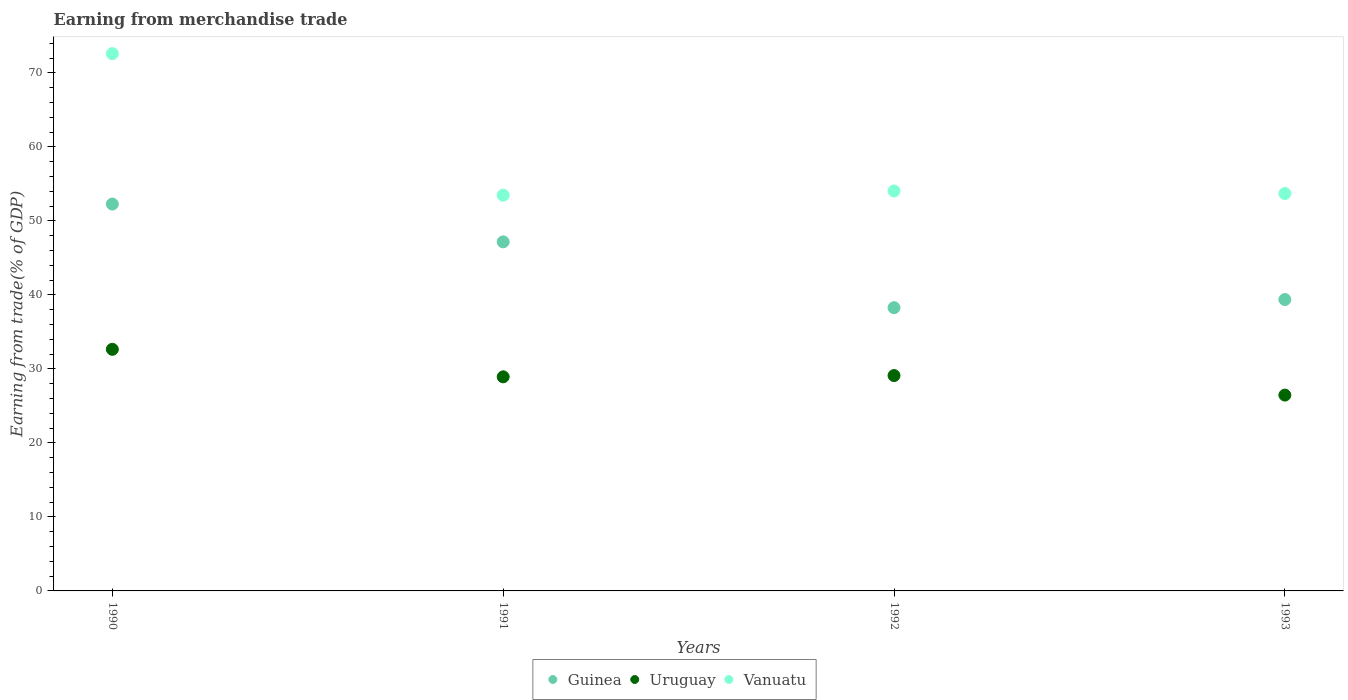What is the earnings from trade in Guinea in 1991?
Your response must be concise. 47.17. Across all years, what is the maximum earnings from trade in Guinea?
Your answer should be compact. 52.28. Across all years, what is the minimum earnings from trade in Uruguay?
Make the answer very short. 26.46. In which year was the earnings from trade in Vanuatu maximum?
Offer a very short reply. 1990. What is the total earnings from trade in Uruguay in the graph?
Offer a very short reply. 117.15. What is the difference between the earnings from trade in Vanuatu in 1990 and that in 1991?
Make the answer very short. 19.13. What is the difference between the earnings from trade in Guinea in 1991 and the earnings from trade in Vanuatu in 1990?
Provide a short and direct response. -25.43. What is the average earnings from trade in Uruguay per year?
Offer a terse response. 29.29. In the year 1993, what is the difference between the earnings from trade in Vanuatu and earnings from trade in Guinea?
Your answer should be compact. 14.33. In how many years, is the earnings from trade in Vanuatu greater than 66 %?
Offer a terse response. 1. What is the ratio of the earnings from trade in Vanuatu in 1990 to that in 1992?
Offer a very short reply. 1.34. Is the difference between the earnings from trade in Vanuatu in 1990 and 1991 greater than the difference between the earnings from trade in Guinea in 1990 and 1991?
Ensure brevity in your answer.  Yes. What is the difference between the highest and the second highest earnings from trade in Guinea?
Provide a short and direct response. 5.11. What is the difference between the highest and the lowest earnings from trade in Uruguay?
Offer a very short reply. 6.19. Is it the case that in every year, the sum of the earnings from trade in Uruguay and earnings from trade in Vanuatu  is greater than the earnings from trade in Guinea?
Your answer should be compact. Yes. Is the earnings from trade in Uruguay strictly greater than the earnings from trade in Vanuatu over the years?
Your answer should be compact. No. Is the earnings from trade in Uruguay strictly less than the earnings from trade in Guinea over the years?
Keep it short and to the point. Yes. How many dotlines are there?
Your answer should be compact. 3. How many years are there in the graph?
Keep it short and to the point. 4. What is the difference between two consecutive major ticks on the Y-axis?
Your response must be concise. 10. Does the graph contain any zero values?
Offer a terse response. No. How many legend labels are there?
Provide a short and direct response. 3. How are the legend labels stacked?
Your response must be concise. Horizontal. What is the title of the graph?
Make the answer very short. Earning from merchandise trade. Does "Nigeria" appear as one of the legend labels in the graph?
Ensure brevity in your answer.  No. What is the label or title of the Y-axis?
Your answer should be compact. Earning from trade(% of GDP). What is the Earning from trade(% of GDP) of Guinea in 1990?
Give a very brief answer. 52.28. What is the Earning from trade(% of GDP) in Uruguay in 1990?
Offer a very short reply. 32.65. What is the Earning from trade(% of GDP) of Vanuatu in 1990?
Your answer should be very brief. 72.6. What is the Earning from trade(% of GDP) of Guinea in 1991?
Your answer should be very brief. 47.17. What is the Earning from trade(% of GDP) in Uruguay in 1991?
Offer a very short reply. 28.93. What is the Earning from trade(% of GDP) in Vanuatu in 1991?
Provide a short and direct response. 53.48. What is the Earning from trade(% of GDP) in Guinea in 1992?
Your answer should be compact. 38.28. What is the Earning from trade(% of GDP) of Uruguay in 1992?
Give a very brief answer. 29.1. What is the Earning from trade(% of GDP) in Vanuatu in 1992?
Keep it short and to the point. 54.04. What is the Earning from trade(% of GDP) in Guinea in 1993?
Offer a terse response. 39.37. What is the Earning from trade(% of GDP) of Uruguay in 1993?
Offer a terse response. 26.46. What is the Earning from trade(% of GDP) in Vanuatu in 1993?
Give a very brief answer. 53.7. Across all years, what is the maximum Earning from trade(% of GDP) in Guinea?
Offer a terse response. 52.28. Across all years, what is the maximum Earning from trade(% of GDP) in Uruguay?
Make the answer very short. 32.65. Across all years, what is the maximum Earning from trade(% of GDP) in Vanuatu?
Give a very brief answer. 72.6. Across all years, what is the minimum Earning from trade(% of GDP) in Guinea?
Your answer should be compact. 38.28. Across all years, what is the minimum Earning from trade(% of GDP) in Uruguay?
Make the answer very short. 26.46. Across all years, what is the minimum Earning from trade(% of GDP) of Vanuatu?
Provide a succinct answer. 53.48. What is the total Earning from trade(% of GDP) in Guinea in the graph?
Provide a succinct answer. 177.09. What is the total Earning from trade(% of GDP) of Uruguay in the graph?
Keep it short and to the point. 117.15. What is the total Earning from trade(% of GDP) in Vanuatu in the graph?
Your answer should be compact. 233.82. What is the difference between the Earning from trade(% of GDP) of Guinea in 1990 and that in 1991?
Give a very brief answer. 5.11. What is the difference between the Earning from trade(% of GDP) in Uruguay in 1990 and that in 1991?
Make the answer very short. 3.72. What is the difference between the Earning from trade(% of GDP) in Vanuatu in 1990 and that in 1991?
Your response must be concise. 19.13. What is the difference between the Earning from trade(% of GDP) in Guinea in 1990 and that in 1992?
Ensure brevity in your answer.  14. What is the difference between the Earning from trade(% of GDP) of Uruguay in 1990 and that in 1992?
Your answer should be compact. 3.55. What is the difference between the Earning from trade(% of GDP) in Vanuatu in 1990 and that in 1992?
Your answer should be compact. 18.56. What is the difference between the Earning from trade(% of GDP) in Guinea in 1990 and that in 1993?
Ensure brevity in your answer.  12.9. What is the difference between the Earning from trade(% of GDP) of Uruguay in 1990 and that in 1993?
Provide a succinct answer. 6.19. What is the difference between the Earning from trade(% of GDP) of Vanuatu in 1990 and that in 1993?
Provide a succinct answer. 18.9. What is the difference between the Earning from trade(% of GDP) in Guinea in 1991 and that in 1992?
Give a very brief answer. 8.89. What is the difference between the Earning from trade(% of GDP) of Uruguay in 1991 and that in 1992?
Offer a terse response. -0.17. What is the difference between the Earning from trade(% of GDP) of Vanuatu in 1991 and that in 1992?
Give a very brief answer. -0.57. What is the difference between the Earning from trade(% of GDP) in Guinea in 1991 and that in 1993?
Your answer should be very brief. 7.8. What is the difference between the Earning from trade(% of GDP) in Uruguay in 1991 and that in 1993?
Provide a succinct answer. 2.47. What is the difference between the Earning from trade(% of GDP) of Vanuatu in 1991 and that in 1993?
Offer a terse response. -0.22. What is the difference between the Earning from trade(% of GDP) in Guinea in 1992 and that in 1993?
Keep it short and to the point. -1.1. What is the difference between the Earning from trade(% of GDP) of Uruguay in 1992 and that in 1993?
Your answer should be very brief. 2.64. What is the difference between the Earning from trade(% of GDP) of Vanuatu in 1992 and that in 1993?
Keep it short and to the point. 0.34. What is the difference between the Earning from trade(% of GDP) of Guinea in 1990 and the Earning from trade(% of GDP) of Uruguay in 1991?
Ensure brevity in your answer.  23.34. What is the difference between the Earning from trade(% of GDP) of Guinea in 1990 and the Earning from trade(% of GDP) of Vanuatu in 1991?
Your answer should be very brief. -1.2. What is the difference between the Earning from trade(% of GDP) of Uruguay in 1990 and the Earning from trade(% of GDP) of Vanuatu in 1991?
Offer a very short reply. -20.83. What is the difference between the Earning from trade(% of GDP) in Guinea in 1990 and the Earning from trade(% of GDP) in Uruguay in 1992?
Your answer should be compact. 23.17. What is the difference between the Earning from trade(% of GDP) of Guinea in 1990 and the Earning from trade(% of GDP) of Vanuatu in 1992?
Make the answer very short. -1.77. What is the difference between the Earning from trade(% of GDP) of Uruguay in 1990 and the Earning from trade(% of GDP) of Vanuatu in 1992?
Provide a succinct answer. -21.39. What is the difference between the Earning from trade(% of GDP) in Guinea in 1990 and the Earning from trade(% of GDP) in Uruguay in 1993?
Ensure brevity in your answer.  25.81. What is the difference between the Earning from trade(% of GDP) of Guinea in 1990 and the Earning from trade(% of GDP) of Vanuatu in 1993?
Keep it short and to the point. -1.42. What is the difference between the Earning from trade(% of GDP) of Uruguay in 1990 and the Earning from trade(% of GDP) of Vanuatu in 1993?
Your answer should be very brief. -21.05. What is the difference between the Earning from trade(% of GDP) of Guinea in 1991 and the Earning from trade(% of GDP) of Uruguay in 1992?
Provide a short and direct response. 18.07. What is the difference between the Earning from trade(% of GDP) of Guinea in 1991 and the Earning from trade(% of GDP) of Vanuatu in 1992?
Offer a terse response. -6.87. What is the difference between the Earning from trade(% of GDP) in Uruguay in 1991 and the Earning from trade(% of GDP) in Vanuatu in 1992?
Offer a terse response. -25.11. What is the difference between the Earning from trade(% of GDP) in Guinea in 1991 and the Earning from trade(% of GDP) in Uruguay in 1993?
Your answer should be very brief. 20.71. What is the difference between the Earning from trade(% of GDP) in Guinea in 1991 and the Earning from trade(% of GDP) in Vanuatu in 1993?
Give a very brief answer. -6.53. What is the difference between the Earning from trade(% of GDP) of Uruguay in 1991 and the Earning from trade(% of GDP) of Vanuatu in 1993?
Your response must be concise. -24.77. What is the difference between the Earning from trade(% of GDP) of Guinea in 1992 and the Earning from trade(% of GDP) of Uruguay in 1993?
Offer a very short reply. 11.81. What is the difference between the Earning from trade(% of GDP) in Guinea in 1992 and the Earning from trade(% of GDP) in Vanuatu in 1993?
Offer a very short reply. -15.43. What is the difference between the Earning from trade(% of GDP) in Uruguay in 1992 and the Earning from trade(% of GDP) in Vanuatu in 1993?
Provide a short and direct response. -24.6. What is the average Earning from trade(% of GDP) of Guinea per year?
Keep it short and to the point. 44.27. What is the average Earning from trade(% of GDP) of Uruguay per year?
Keep it short and to the point. 29.29. What is the average Earning from trade(% of GDP) in Vanuatu per year?
Provide a succinct answer. 58.46. In the year 1990, what is the difference between the Earning from trade(% of GDP) of Guinea and Earning from trade(% of GDP) of Uruguay?
Give a very brief answer. 19.63. In the year 1990, what is the difference between the Earning from trade(% of GDP) in Guinea and Earning from trade(% of GDP) in Vanuatu?
Make the answer very short. -20.33. In the year 1990, what is the difference between the Earning from trade(% of GDP) in Uruguay and Earning from trade(% of GDP) in Vanuatu?
Your answer should be compact. -39.95. In the year 1991, what is the difference between the Earning from trade(% of GDP) of Guinea and Earning from trade(% of GDP) of Uruguay?
Offer a terse response. 18.24. In the year 1991, what is the difference between the Earning from trade(% of GDP) in Guinea and Earning from trade(% of GDP) in Vanuatu?
Provide a succinct answer. -6.31. In the year 1991, what is the difference between the Earning from trade(% of GDP) in Uruguay and Earning from trade(% of GDP) in Vanuatu?
Offer a terse response. -24.54. In the year 1992, what is the difference between the Earning from trade(% of GDP) in Guinea and Earning from trade(% of GDP) in Uruguay?
Provide a succinct answer. 9.17. In the year 1992, what is the difference between the Earning from trade(% of GDP) in Guinea and Earning from trade(% of GDP) in Vanuatu?
Keep it short and to the point. -15.77. In the year 1992, what is the difference between the Earning from trade(% of GDP) in Uruguay and Earning from trade(% of GDP) in Vanuatu?
Provide a short and direct response. -24.94. In the year 1993, what is the difference between the Earning from trade(% of GDP) of Guinea and Earning from trade(% of GDP) of Uruguay?
Your answer should be very brief. 12.91. In the year 1993, what is the difference between the Earning from trade(% of GDP) of Guinea and Earning from trade(% of GDP) of Vanuatu?
Give a very brief answer. -14.33. In the year 1993, what is the difference between the Earning from trade(% of GDP) in Uruguay and Earning from trade(% of GDP) in Vanuatu?
Make the answer very short. -27.24. What is the ratio of the Earning from trade(% of GDP) of Guinea in 1990 to that in 1991?
Provide a succinct answer. 1.11. What is the ratio of the Earning from trade(% of GDP) of Uruguay in 1990 to that in 1991?
Provide a short and direct response. 1.13. What is the ratio of the Earning from trade(% of GDP) in Vanuatu in 1990 to that in 1991?
Offer a very short reply. 1.36. What is the ratio of the Earning from trade(% of GDP) of Guinea in 1990 to that in 1992?
Provide a short and direct response. 1.37. What is the ratio of the Earning from trade(% of GDP) of Uruguay in 1990 to that in 1992?
Provide a short and direct response. 1.12. What is the ratio of the Earning from trade(% of GDP) of Vanuatu in 1990 to that in 1992?
Give a very brief answer. 1.34. What is the ratio of the Earning from trade(% of GDP) in Guinea in 1990 to that in 1993?
Offer a terse response. 1.33. What is the ratio of the Earning from trade(% of GDP) of Uruguay in 1990 to that in 1993?
Ensure brevity in your answer.  1.23. What is the ratio of the Earning from trade(% of GDP) of Vanuatu in 1990 to that in 1993?
Your answer should be compact. 1.35. What is the ratio of the Earning from trade(% of GDP) in Guinea in 1991 to that in 1992?
Offer a terse response. 1.23. What is the ratio of the Earning from trade(% of GDP) in Guinea in 1991 to that in 1993?
Your answer should be very brief. 1.2. What is the ratio of the Earning from trade(% of GDP) in Uruguay in 1991 to that in 1993?
Keep it short and to the point. 1.09. What is the ratio of the Earning from trade(% of GDP) of Guinea in 1992 to that in 1993?
Ensure brevity in your answer.  0.97. What is the ratio of the Earning from trade(% of GDP) in Uruguay in 1992 to that in 1993?
Offer a very short reply. 1.1. What is the ratio of the Earning from trade(% of GDP) of Vanuatu in 1992 to that in 1993?
Offer a terse response. 1.01. What is the difference between the highest and the second highest Earning from trade(% of GDP) of Guinea?
Offer a terse response. 5.11. What is the difference between the highest and the second highest Earning from trade(% of GDP) of Uruguay?
Provide a short and direct response. 3.55. What is the difference between the highest and the second highest Earning from trade(% of GDP) in Vanuatu?
Ensure brevity in your answer.  18.56. What is the difference between the highest and the lowest Earning from trade(% of GDP) in Guinea?
Your answer should be very brief. 14. What is the difference between the highest and the lowest Earning from trade(% of GDP) in Uruguay?
Ensure brevity in your answer.  6.19. What is the difference between the highest and the lowest Earning from trade(% of GDP) in Vanuatu?
Offer a very short reply. 19.13. 